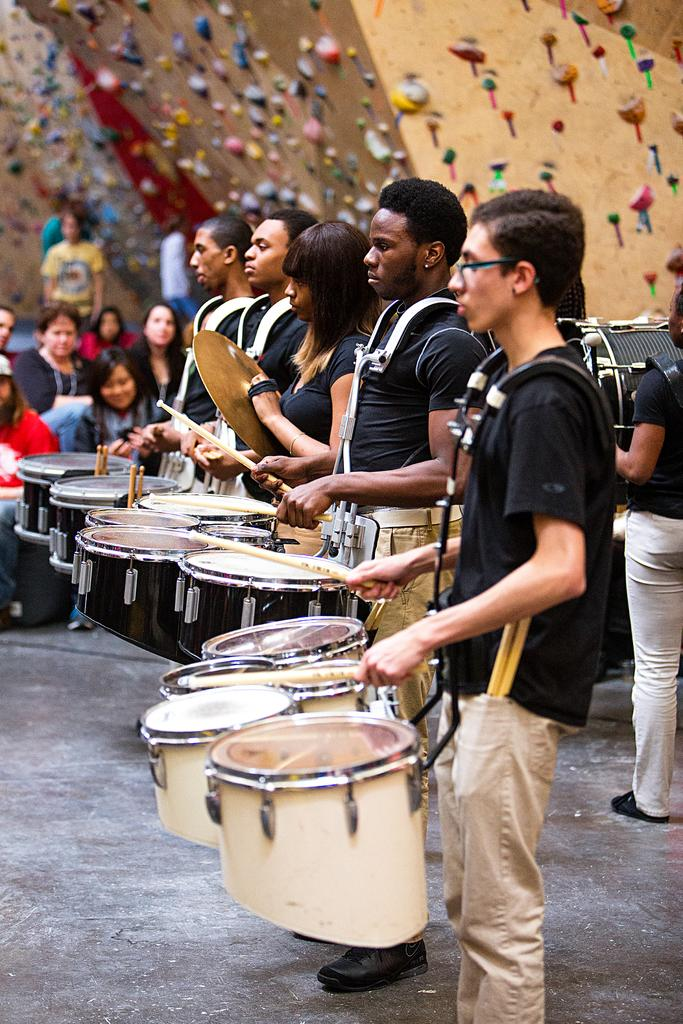How many people are involved in the activity shown in the image? There are five people in the image. What are the people doing in the image? The people are playing a snare drum with drumsticks. Are there any spectators in the image? Yes, there are people sitting and watching the drummers. What type of ray can be seen swimming in the background of the image? There is no ray present in the image; it features people playing a snare drum. 